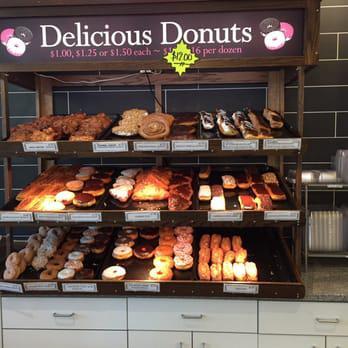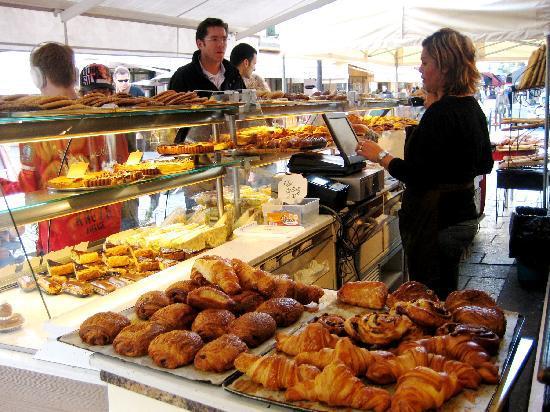The first image is the image on the left, the second image is the image on the right. Examine the images to the left and right. Is the description "There are windows in the image on the right." accurate? Answer yes or no. Yes. 